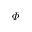<formula> <loc_0><loc_0><loc_500><loc_500>\varPhi</formula> 